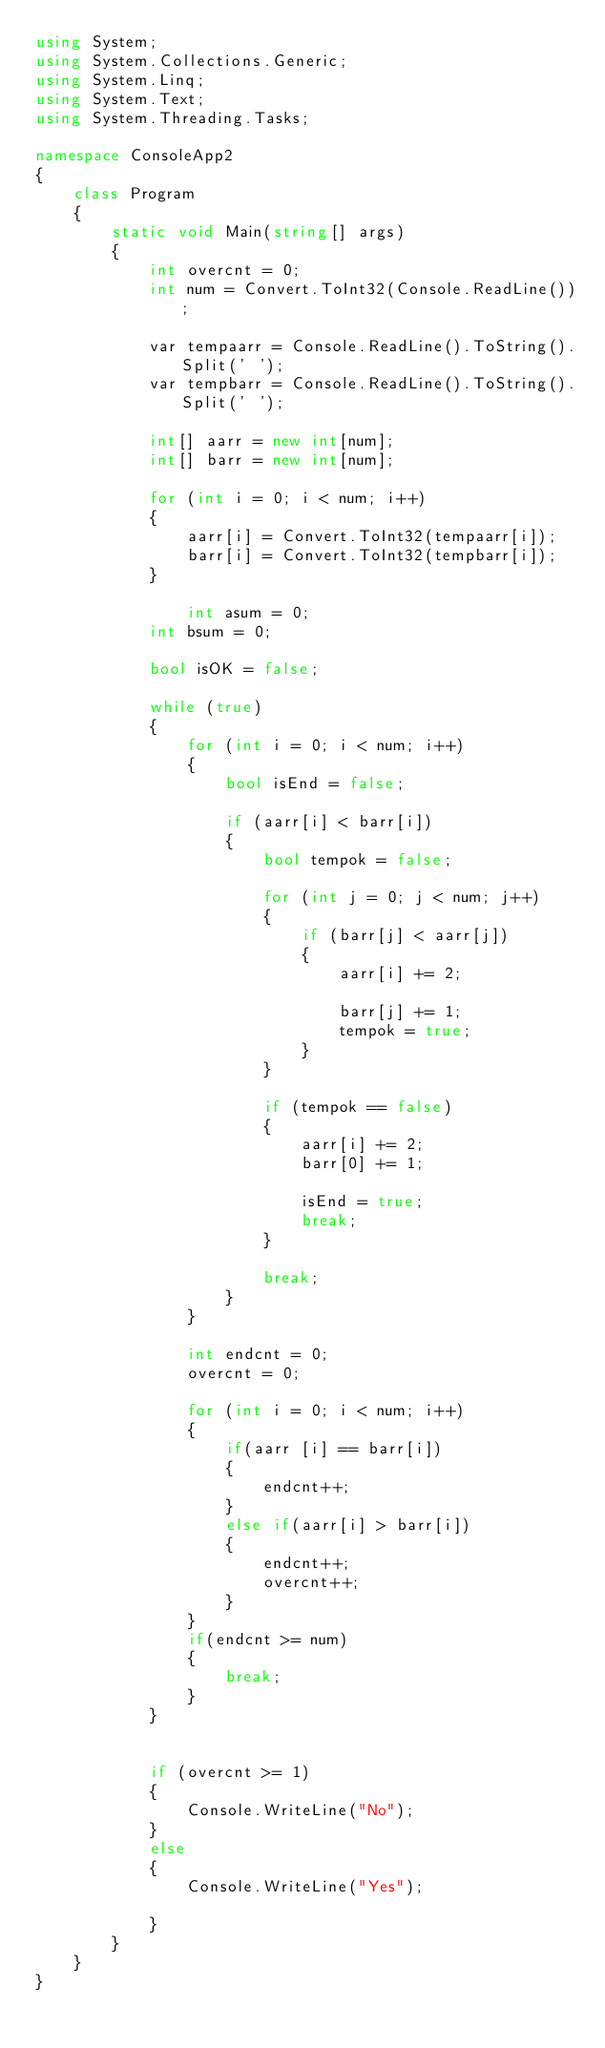<code> <loc_0><loc_0><loc_500><loc_500><_C#_>using System;
using System.Collections.Generic;
using System.Linq;
using System.Text;
using System.Threading.Tasks;

namespace ConsoleApp2
{
    class Program
    {
        static void Main(string[] args)
        {
            int overcnt = 0;
            int num = Convert.ToInt32(Console.ReadLine());

            var tempaarr = Console.ReadLine().ToString().Split(' ');
            var tempbarr = Console.ReadLine().ToString().Split(' ');

            int[] aarr = new int[num];
            int[] barr = new int[num];

            for (int i = 0; i < num; i++)
            {
                aarr[i] = Convert.ToInt32(tempaarr[i]);
                barr[i] = Convert.ToInt32(tempbarr[i]);
            }

                int asum = 0;
            int bsum = 0;

            bool isOK = false;

            while (true)
            {
                for (int i = 0; i < num; i++)
                {
                    bool isEnd = false;

                    if (aarr[i] < barr[i])
                    {
                        bool tempok = false;

                        for (int j = 0; j < num; j++)
                        {
                            if (barr[j] < aarr[j])
                            {
                                aarr[i] += 2;

                                barr[j] += 1;
                                tempok = true;
                            }
                        }

                        if (tempok == false)
                        {
                            aarr[i] += 2;
                            barr[0] += 1;

                            isEnd = true;
                            break;
                        }

                        break;
                    }
                }

                int endcnt = 0;
                overcnt = 0;

                for (int i = 0; i < num; i++)
                {
                    if(aarr [i] == barr[i])
                    {
                        endcnt++;
                    }
                    else if(aarr[i] > barr[i])
                    {
                        endcnt++;
                        overcnt++;
                    }
                }
                if(endcnt >= num)
                {
                    break;
                }
            }


            if (overcnt >= 1)
            {
                Console.WriteLine("No");
            }
            else
            {
                Console.WriteLine("Yes");

            }
        }
    }
}
</code> 